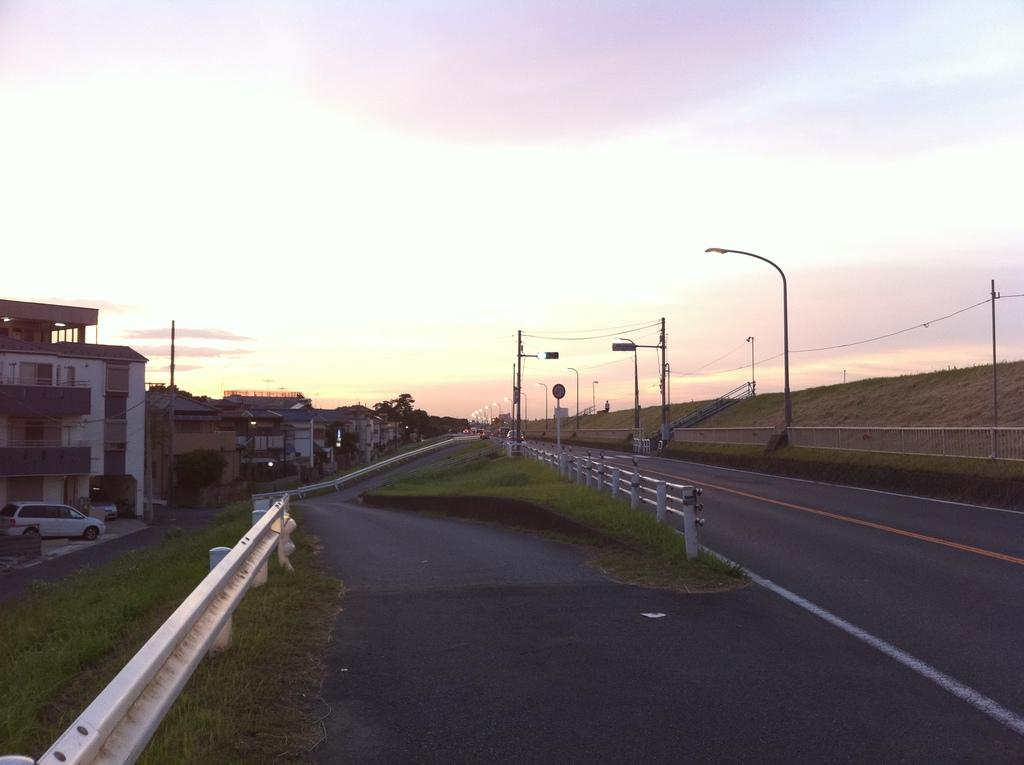What is the main feature of the image? There is a road in the image. What else can be seen on the road? There is a vehicle in the image. What structures are present in the image? There are buildings, trees, and light poles in the image. Can you describe the railing in the image? Yes, there is a railing in the image. What is the color of the sky in the image? The sky is visible in the image, and it has a white and blue color. What type of behavior can be observed in the jar in the image? There is no jar present in the image, so no behavior can be observed. 